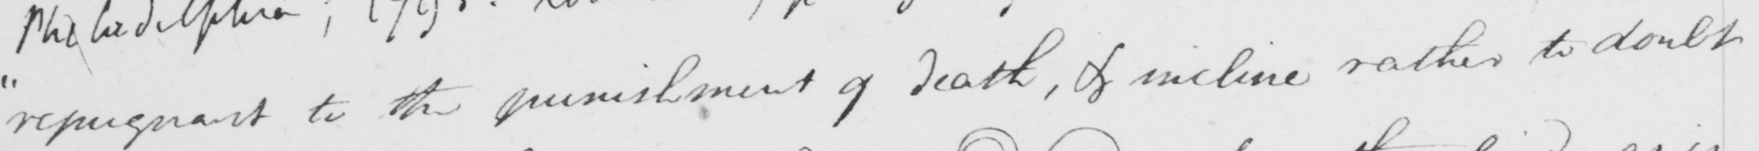Can you tell me what this handwritten text says? " repugnant to the punishment of death , & incline rather to doubt 